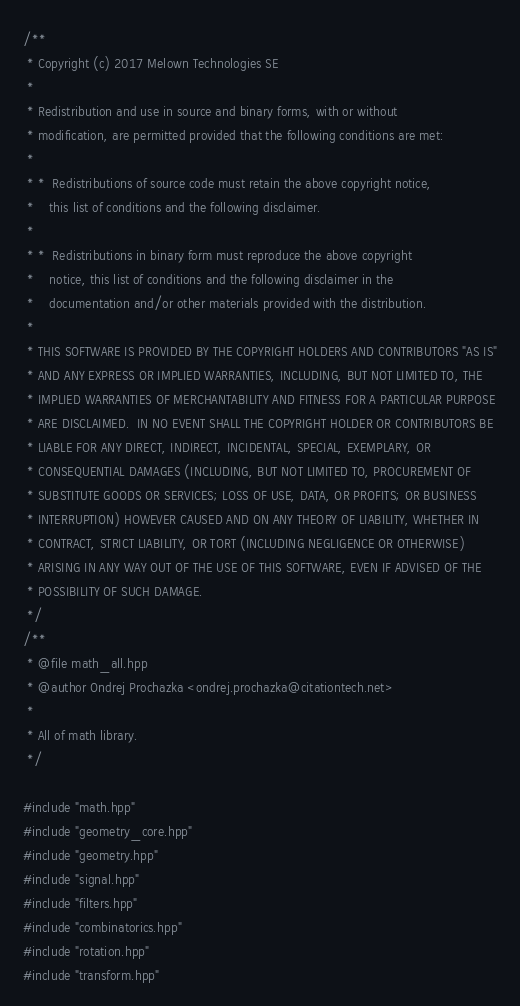Convert code to text. <code><loc_0><loc_0><loc_500><loc_500><_C++_>/**
 * Copyright (c) 2017 Melown Technologies SE
 *
 * Redistribution and use in source and binary forms, with or without
 * modification, are permitted provided that the following conditions are met:
 *
 * *  Redistributions of source code must retain the above copyright notice,
 *    this list of conditions and the following disclaimer.
 *
 * *  Redistributions in binary form must reproduce the above copyright
 *    notice, this list of conditions and the following disclaimer in the
 *    documentation and/or other materials provided with the distribution.
 *
 * THIS SOFTWARE IS PROVIDED BY THE COPYRIGHT HOLDERS AND CONTRIBUTORS "AS IS"
 * AND ANY EXPRESS OR IMPLIED WARRANTIES, INCLUDING, BUT NOT LIMITED TO, THE
 * IMPLIED WARRANTIES OF MERCHANTABILITY AND FITNESS FOR A PARTICULAR PURPOSE
 * ARE DISCLAIMED.  IN NO EVENT SHALL THE COPYRIGHT HOLDER OR CONTRIBUTORS BE
 * LIABLE FOR ANY DIRECT, INDIRECT, INCIDENTAL, SPECIAL, EXEMPLARY, OR
 * CONSEQUENTIAL DAMAGES (INCLUDING, BUT NOT LIMITED TO, PROCUREMENT OF
 * SUBSTITUTE GOODS OR SERVICES; LOSS OF USE, DATA, OR PROFITS; OR BUSINESS
 * INTERRUPTION) HOWEVER CAUSED AND ON ANY THEORY OF LIABILITY, WHETHER IN
 * CONTRACT, STRICT LIABILITY, OR TORT (INCLUDING NEGLIGENCE OR OTHERWISE)
 * ARISING IN ANY WAY OUT OF THE USE OF THIS SOFTWARE, EVEN IF ADVISED OF THE
 * POSSIBILITY OF SUCH DAMAGE.
 */
/**
 * @file math_all.hpp
 * @author Ondrej Prochazka <ondrej.prochazka@citationtech.net>
 *
 * All of math library.
 */
 
#include "math.hpp"
#include "geometry_core.hpp"
#include "geometry.hpp"
#include "signal.hpp"
#include "filters.hpp"
#include "combinatorics.hpp"
#include "rotation.hpp"
#include "transform.hpp"
</code> 